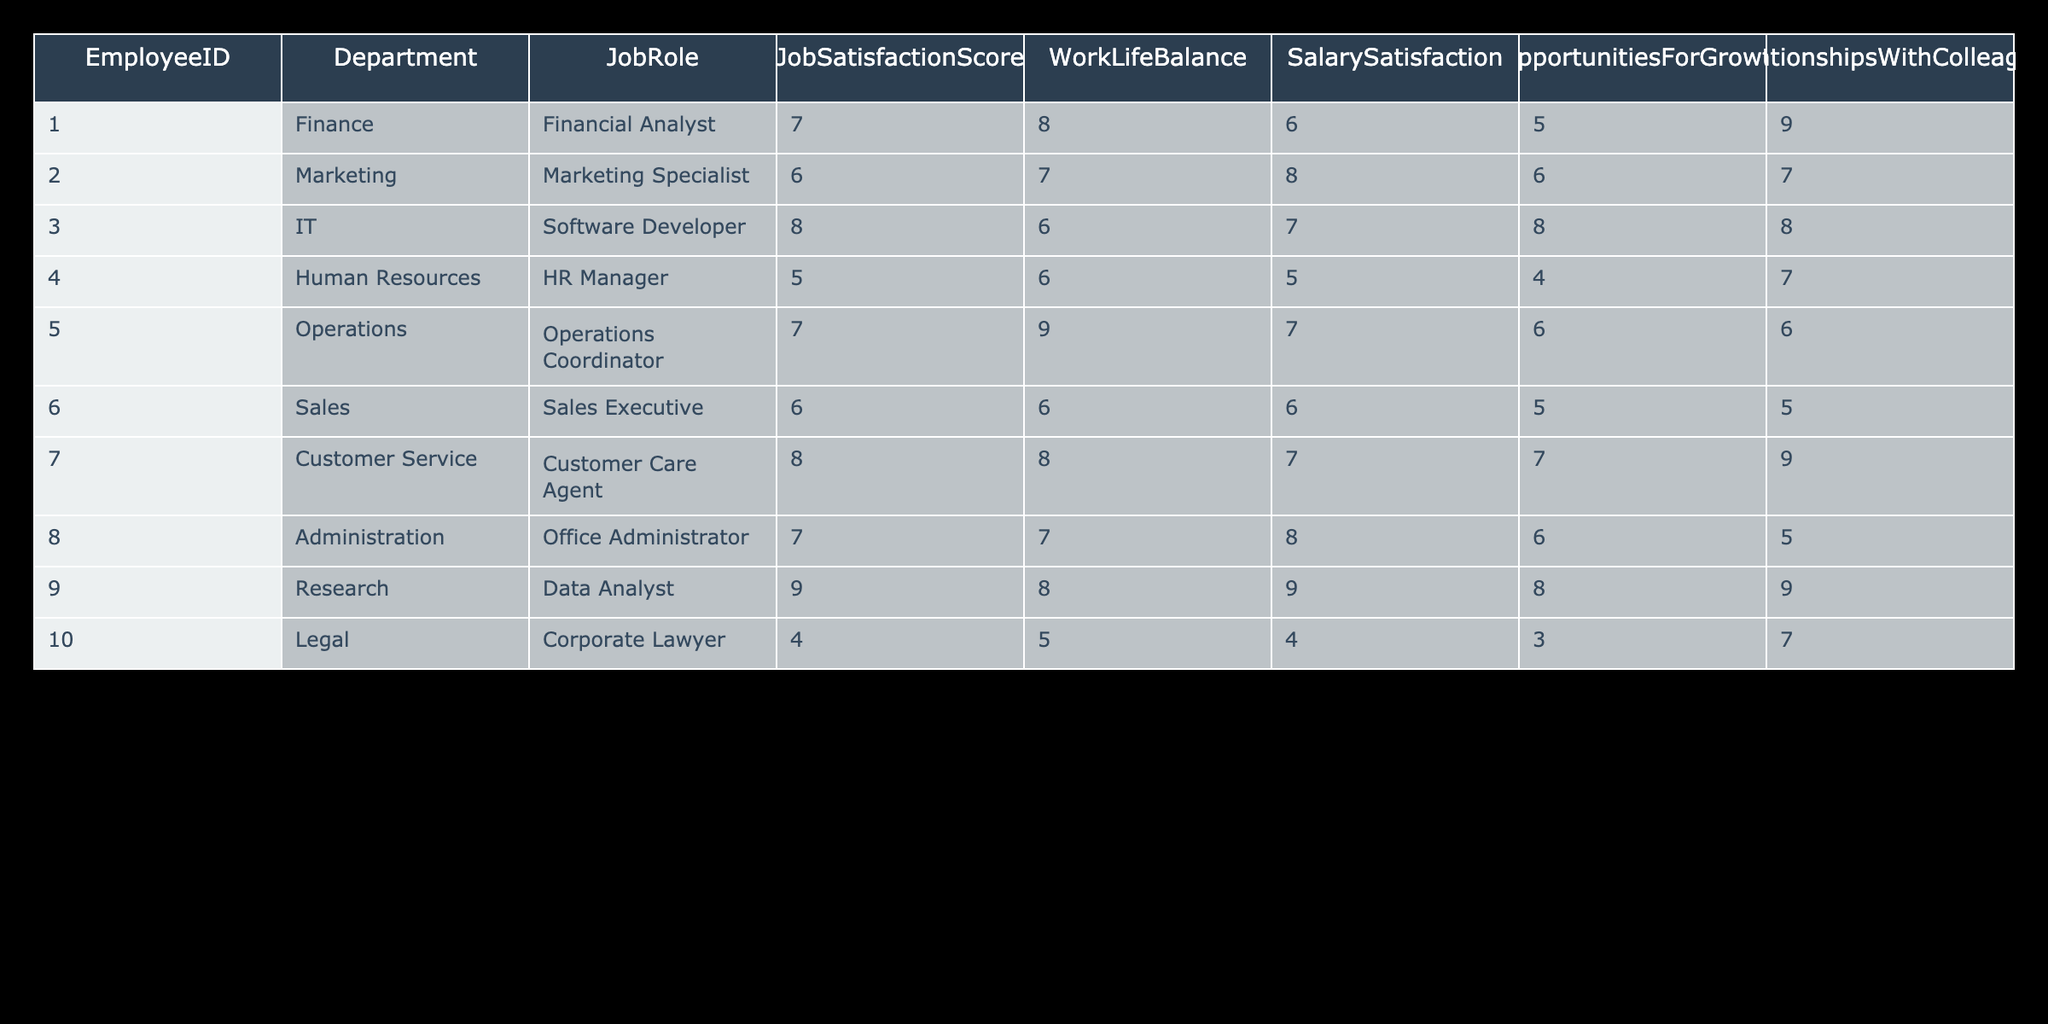What is the Job Satisfaction Score of the HR Manager? The HR Manager, identified by EmployeeID 4 in the table, has a Job Satisfaction Score of 5.
Answer: 5 Which department has the highest Job Satisfaction Score? In the table, the Data Analyst in the Research department has the highest Job Satisfaction Score of 9.
Answer: Research What is the average Salary Satisfaction score for the office workers? The Salary Satisfaction scores are 6, 8, 7, 5, 7, 6, 7, 8, 9, 4. Adding these gives 6 + 8 + 7 + 5 + 7 + 6 + 7 + 8 + 9 + 4 = 67, and dividing by 10 (the number of employees) gives an average of 6.7.
Answer: 6.7 Is the Work-Life Balance for the Sales Executive higher than 7? The Work-Life Balance score for the Sales Executive, which is 6, is not higher than 7.
Answer: No How many employees have a Job Satisfaction Score of 7 or higher? The employees with a Job Satisfaction Score of 7 or higher are the Financial Analyst, Software Developer, Customer Care Agent, Office Administrator, Data Analyst, and Operations Coordinator; totaling 6 employees.
Answer: 6 What is the difference between the highest and lowest Job Satisfaction Scores? The highest Job Satisfaction Score is 9 (Data Analyst) and the lowest is 4 (Corporate Lawyer). The difference is 9 - 4 = 5.
Answer: 5 Which Job Role has the highest score in Opportunities for Growth? The Software Developer has an Opportunities for Growth score of 8, which is the highest among all Job Roles listed.
Answer: Software Developer Is it true that all employees in the Finance department have a Job Satisfaction Score above 5? There’s only one employee in Finance (Financial Analyst), who has a Job Satisfaction Score of 7, which is above 5. So, the statement is true.
Answer: Yes What is the median Job Satisfaction Score of all the office workers? Sorting the Job Satisfaction Scores gives: 4, 5, 6, 6, 7, 7, 7, 8, 8, 9. The median is the average of the 5th and 6th scores; (7 + 7)/2 = 7.
Answer: 7 